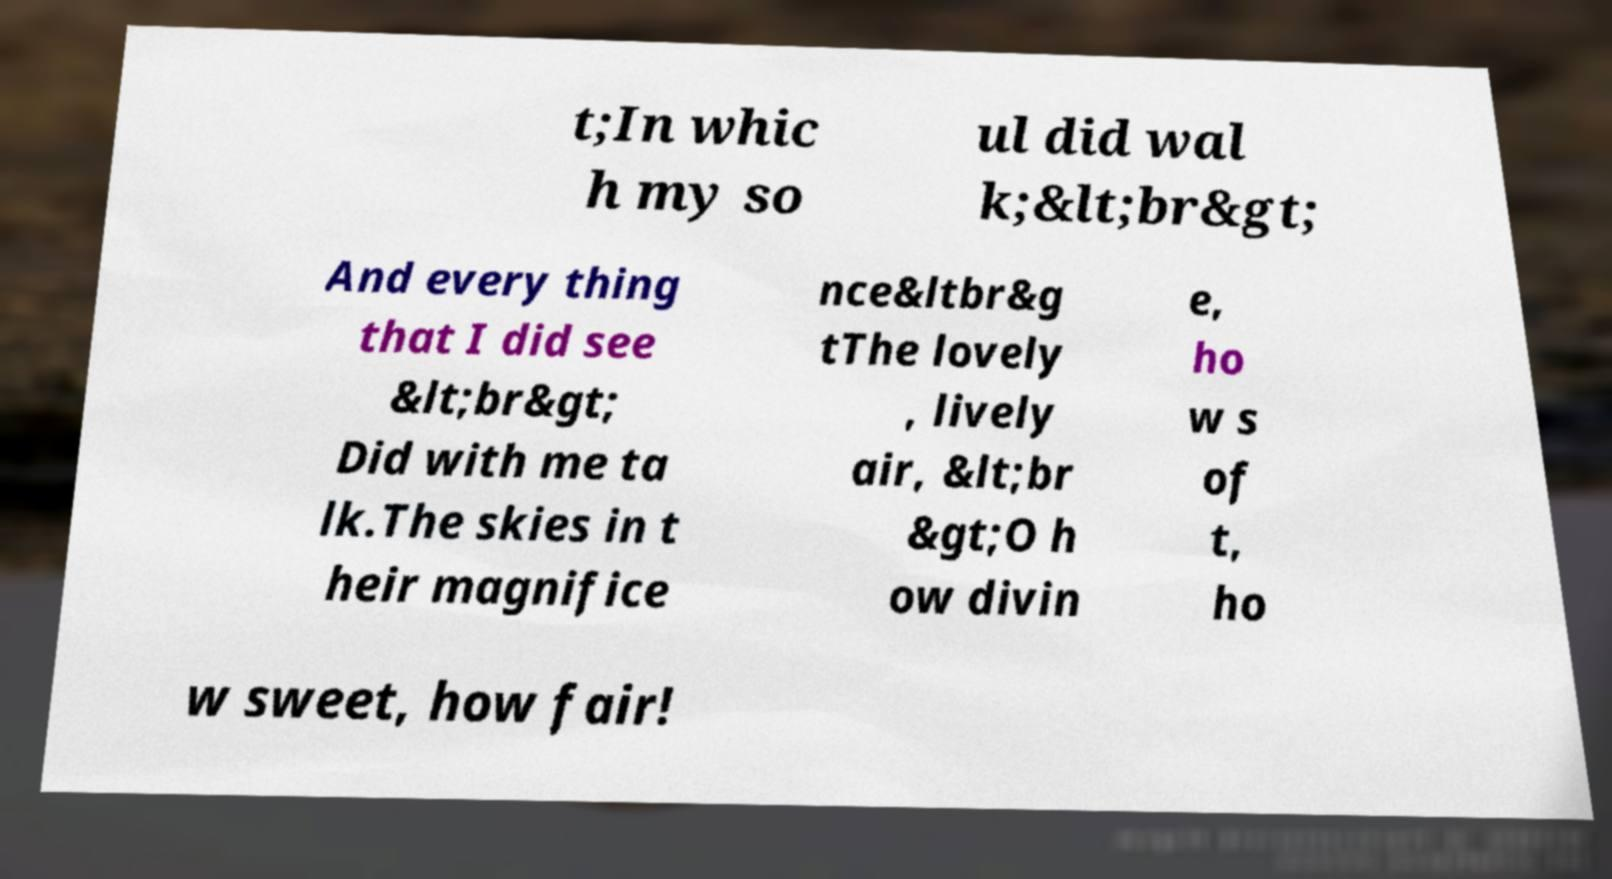Can you accurately transcribe the text from the provided image for me? t;In whic h my so ul did wal k;&lt;br&gt; And every thing that I did see &lt;br&gt; Did with me ta lk.The skies in t heir magnifice nce&ltbr&g tThe lovely , lively air, &lt;br &gt;O h ow divin e, ho w s of t, ho w sweet, how fair! 